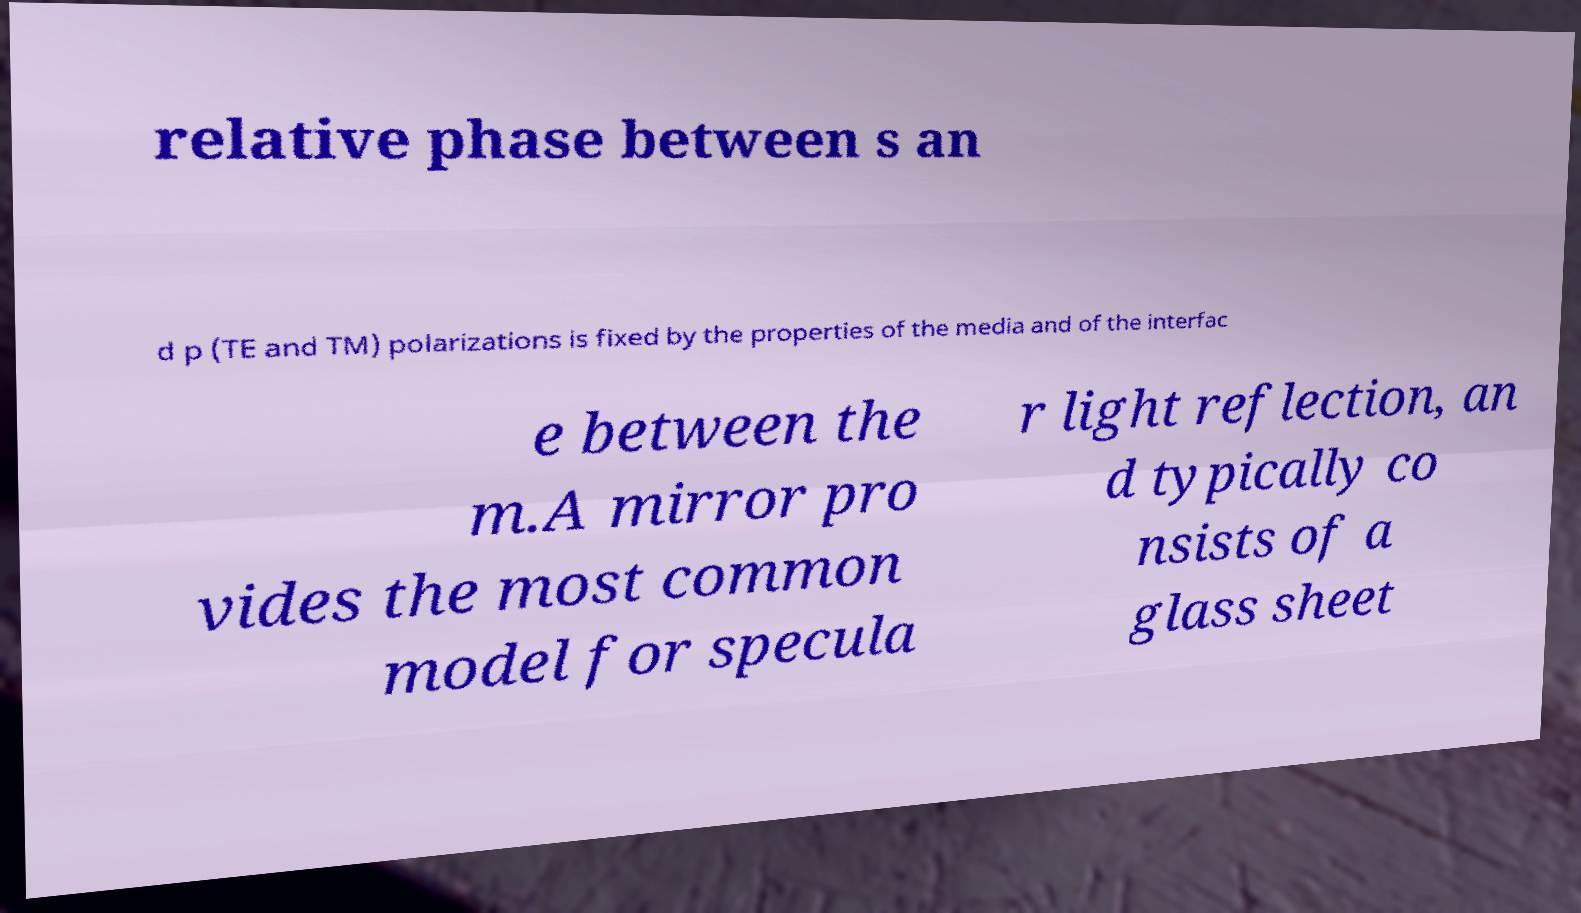What messages or text are displayed in this image? I need them in a readable, typed format. relative phase between s an d p (TE and TM) polarizations is fixed by the properties of the media and of the interfac e between the m.A mirror pro vides the most common model for specula r light reflection, an d typically co nsists of a glass sheet 